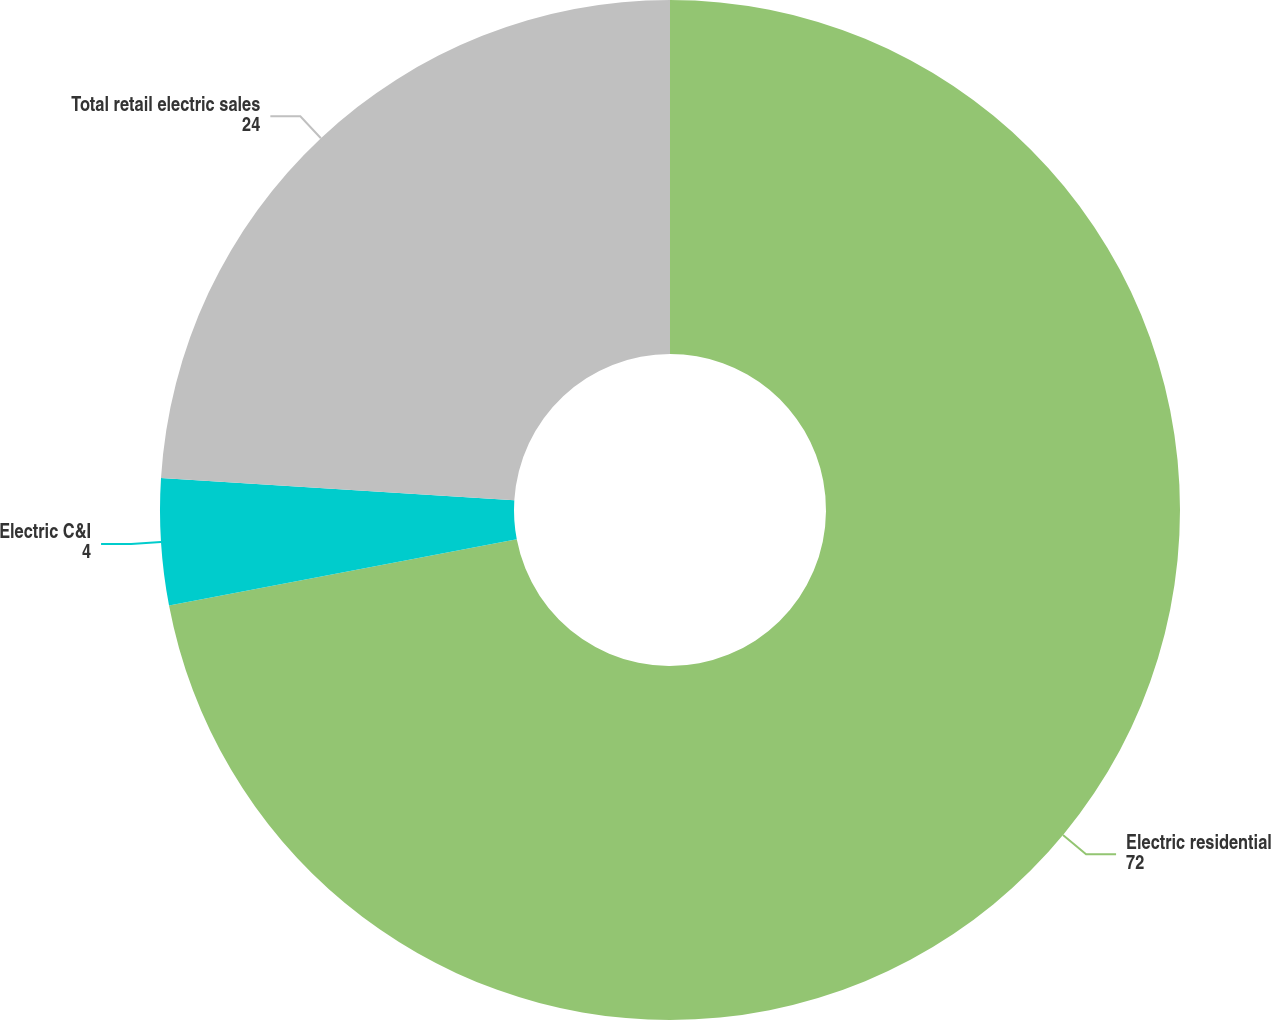Convert chart. <chart><loc_0><loc_0><loc_500><loc_500><pie_chart><fcel>Electric residential<fcel>Electric C&I<fcel>Total retail electric sales<nl><fcel>72.0%<fcel>4.0%<fcel>24.0%<nl></chart> 